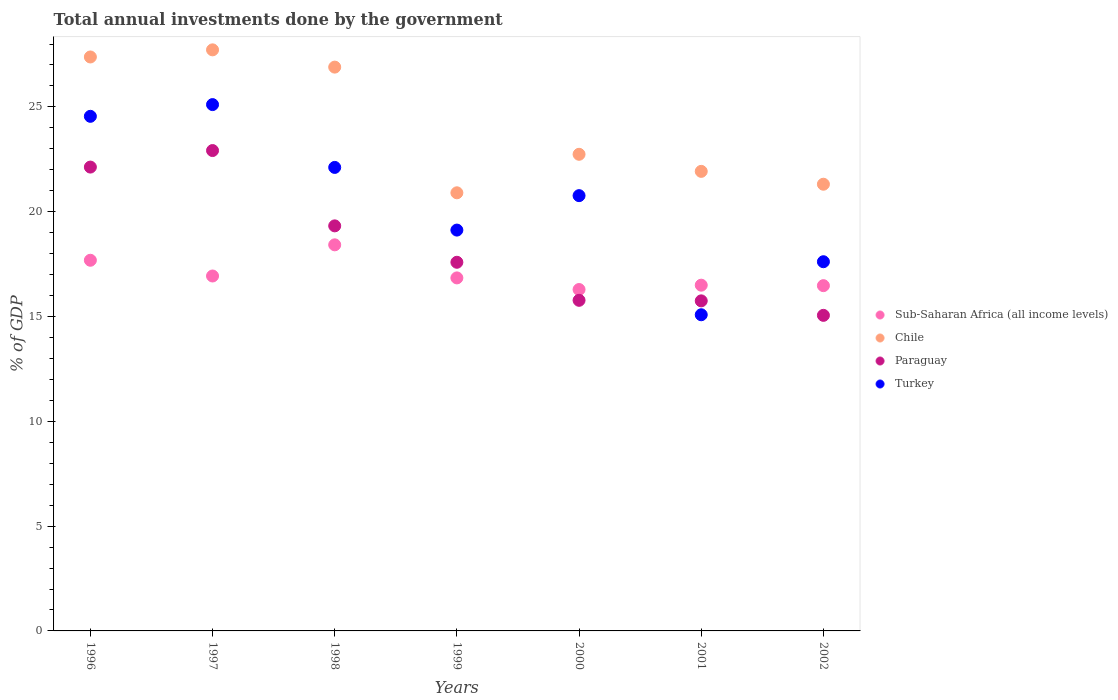Is the number of dotlines equal to the number of legend labels?
Offer a very short reply. Yes. What is the total annual investments done by the government in Paraguay in 2000?
Provide a succinct answer. 15.77. Across all years, what is the maximum total annual investments done by the government in Chile?
Offer a terse response. 27.72. Across all years, what is the minimum total annual investments done by the government in Paraguay?
Offer a very short reply. 15.06. In which year was the total annual investments done by the government in Sub-Saharan Africa (all income levels) minimum?
Offer a terse response. 2000. What is the total total annual investments done by the government in Chile in the graph?
Make the answer very short. 168.88. What is the difference between the total annual investments done by the government in Turkey in 1996 and that in 1998?
Offer a terse response. 2.44. What is the difference between the total annual investments done by the government in Chile in 2002 and the total annual investments done by the government in Turkey in 1996?
Give a very brief answer. -3.24. What is the average total annual investments done by the government in Paraguay per year?
Your answer should be compact. 18.36. In the year 1998, what is the difference between the total annual investments done by the government in Turkey and total annual investments done by the government in Chile?
Offer a terse response. -4.79. In how many years, is the total annual investments done by the government in Turkey greater than 2 %?
Give a very brief answer. 7. What is the ratio of the total annual investments done by the government in Turkey in 1999 to that in 2001?
Your answer should be very brief. 1.27. Is the total annual investments done by the government in Turkey in 1997 less than that in 2000?
Offer a terse response. No. Is the difference between the total annual investments done by the government in Turkey in 1998 and 2001 greater than the difference between the total annual investments done by the government in Chile in 1998 and 2001?
Provide a succinct answer. Yes. What is the difference between the highest and the second highest total annual investments done by the government in Sub-Saharan Africa (all income levels)?
Give a very brief answer. 0.74. What is the difference between the highest and the lowest total annual investments done by the government in Chile?
Make the answer very short. 6.82. In how many years, is the total annual investments done by the government in Paraguay greater than the average total annual investments done by the government in Paraguay taken over all years?
Offer a terse response. 3. Is it the case that in every year, the sum of the total annual investments done by the government in Paraguay and total annual investments done by the government in Turkey  is greater than the total annual investments done by the government in Chile?
Provide a succinct answer. Yes. Does the total annual investments done by the government in Turkey monotonically increase over the years?
Keep it short and to the point. No. Is the total annual investments done by the government in Turkey strictly less than the total annual investments done by the government in Chile over the years?
Your response must be concise. Yes. How many dotlines are there?
Ensure brevity in your answer.  4. How many years are there in the graph?
Offer a very short reply. 7. Are the values on the major ticks of Y-axis written in scientific E-notation?
Make the answer very short. No. Does the graph contain any zero values?
Provide a succinct answer. No. Does the graph contain grids?
Your answer should be very brief. No. Where does the legend appear in the graph?
Your response must be concise. Center right. How many legend labels are there?
Offer a terse response. 4. What is the title of the graph?
Offer a terse response. Total annual investments done by the government. Does "Armenia" appear as one of the legend labels in the graph?
Make the answer very short. No. What is the label or title of the Y-axis?
Your answer should be compact. % of GDP. What is the % of GDP of Sub-Saharan Africa (all income levels) in 1996?
Make the answer very short. 17.68. What is the % of GDP of Chile in 1996?
Make the answer very short. 27.38. What is the % of GDP of Paraguay in 1996?
Give a very brief answer. 22.13. What is the % of GDP of Turkey in 1996?
Keep it short and to the point. 24.55. What is the % of GDP in Sub-Saharan Africa (all income levels) in 1997?
Make the answer very short. 16.93. What is the % of GDP of Chile in 1997?
Offer a terse response. 27.72. What is the % of GDP of Paraguay in 1997?
Offer a terse response. 22.92. What is the % of GDP in Turkey in 1997?
Ensure brevity in your answer.  25.11. What is the % of GDP of Sub-Saharan Africa (all income levels) in 1998?
Your answer should be very brief. 18.42. What is the % of GDP in Chile in 1998?
Give a very brief answer. 26.9. What is the % of GDP in Paraguay in 1998?
Offer a terse response. 19.32. What is the % of GDP of Turkey in 1998?
Offer a very short reply. 22.11. What is the % of GDP of Sub-Saharan Africa (all income levels) in 1999?
Offer a very short reply. 16.84. What is the % of GDP of Chile in 1999?
Keep it short and to the point. 20.9. What is the % of GDP of Paraguay in 1999?
Offer a terse response. 17.59. What is the % of GDP of Turkey in 1999?
Your response must be concise. 19.12. What is the % of GDP of Sub-Saharan Africa (all income levels) in 2000?
Your response must be concise. 16.29. What is the % of GDP in Chile in 2000?
Offer a terse response. 22.74. What is the % of GDP in Paraguay in 2000?
Keep it short and to the point. 15.77. What is the % of GDP in Turkey in 2000?
Keep it short and to the point. 20.77. What is the % of GDP of Sub-Saharan Africa (all income levels) in 2001?
Offer a very short reply. 16.5. What is the % of GDP of Chile in 2001?
Offer a very short reply. 21.92. What is the % of GDP of Paraguay in 2001?
Keep it short and to the point. 15.75. What is the % of GDP of Turkey in 2001?
Give a very brief answer. 15.08. What is the % of GDP of Sub-Saharan Africa (all income levels) in 2002?
Offer a terse response. 16.47. What is the % of GDP of Chile in 2002?
Provide a short and direct response. 21.31. What is the % of GDP in Paraguay in 2002?
Your answer should be compact. 15.06. What is the % of GDP of Turkey in 2002?
Make the answer very short. 17.61. Across all years, what is the maximum % of GDP in Sub-Saharan Africa (all income levels)?
Offer a terse response. 18.42. Across all years, what is the maximum % of GDP in Chile?
Offer a very short reply. 27.72. Across all years, what is the maximum % of GDP of Paraguay?
Ensure brevity in your answer.  22.92. Across all years, what is the maximum % of GDP in Turkey?
Offer a very short reply. 25.11. Across all years, what is the minimum % of GDP of Sub-Saharan Africa (all income levels)?
Your answer should be compact. 16.29. Across all years, what is the minimum % of GDP of Chile?
Your response must be concise. 20.9. Across all years, what is the minimum % of GDP of Paraguay?
Provide a short and direct response. 15.06. Across all years, what is the minimum % of GDP of Turkey?
Keep it short and to the point. 15.08. What is the total % of GDP of Sub-Saharan Africa (all income levels) in the graph?
Your answer should be compact. 119.14. What is the total % of GDP of Chile in the graph?
Your response must be concise. 168.88. What is the total % of GDP of Paraguay in the graph?
Keep it short and to the point. 128.54. What is the total % of GDP in Turkey in the graph?
Give a very brief answer. 144.36. What is the difference between the % of GDP of Sub-Saharan Africa (all income levels) in 1996 and that in 1997?
Keep it short and to the point. 0.75. What is the difference between the % of GDP in Chile in 1996 and that in 1997?
Offer a terse response. -0.34. What is the difference between the % of GDP of Paraguay in 1996 and that in 1997?
Your answer should be very brief. -0.79. What is the difference between the % of GDP in Turkey in 1996 and that in 1997?
Make the answer very short. -0.56. What is the difference between the % of GDP of Sub-Saharan Africa (all income levels) in 1996 and that in 1998?
Keep it short and to the point. -0.74. What is the difference between the % of GDP in Chile in 1996 and that in 1998?
Provide a succinct answer. 0.48. What is the difference between the % of GDP of Paraguay in 1996 and that in 1998?
Keep it short and to the point. 2.8. What is the difference between the % of GDP of Turkey in 1996 and that in 1998?
Your answer should be compact. 2.44. What is the difference between the % of GDP of Sub-Saharan Africa (all income levels) in 1996 and that in 1999?
Provide a succinct answer. 0.84. What is the difference between the % of GDP of Chile in 1996 and that in 1999?
Your response must be concise. 6.48. What is the difference between the % of GDP in Paraguay in 1996 and that in 1999?
Provide a succinct answer. 4.54. What is the difference between the % of GDP of Turkey in 1996 and that in 1999?
Offer a very short reply. 5.43. What is the difference between the % of GDP of Sub-Saharan Africa (all income levels) in 1996 and that in 2000?
Make the answer very short. 1.4. What is the difference between the % of GDP in Chile in 1996 and that in 2000?
Your response must be concise. 4.64. What is the difference between the % of GDP in Paraguay in 1996 and that in 2000?
Ensure brevity in your answer.  6.36. What is the difference between the % of GDP in Turkey in 1996 and that in 2000?
Give a very brief answer. 3.78. What is the difference between the % of GDP in Sub-Saharan Africa (all income levels) in 1996 and that in 2001?
Offer a terse response. 1.19. What is the difference between the % of GDP of Chile in 1996 and that in 2001?
Provide a short and direct response. 5.46. What is the difference between the % of GDP of Paraguay in 1996 and that in 2001?
Your answer should be very brief. 6.38. What is the difference between the % of GDP of Turkey in 1996 and that in 2001?
Your answer should be compact. 9.47. What is the difference between the % of GDP of Sub-Saharan Africa (all income levels) in 1996 and that in 2002?
Keep it short and to the point. 1.21. What is the difference between the % of GDP in Chile in 1996 and that in 2002?
Keep it short and to the point. 6.07. What is the difference between the % of GDP in Paraguay in 1996 and that in 2002?
Make the answer very short. 7.07. What is the difference between the % of GDP of Turkey in 1996 and that in 2002?
Make the answer very short. 6.94. What is the difference between the % of GDP in Sub-Saharan Africa (all income levels) in 1997 and that in 1998?
Your response must be concise. -1.49. What is the difference between the % of GDP of Chile in 1997 and that in 1998?
Provide a short and direct response. 0.82. What is the difference between the % of GDP of Paraguay in 1997 and that in 1998?
Your answer should be compact. 3.59. What is the difference between the % of GDP in Turkey in 1997 and that in 1998?
Your response must be concise. 3. What is the difference between the % of GDP in Sub-Saharan Africa (all income levels) in 1997 and that in 1999?
Your answer should be very brief. 0.09. What is the difference between the % of GDP of Chile in 1997 and that in 1999?
Ensure brevity in your answer.  6.82. What is the difference between the % of GDP in Paraguay in 1997 and that in 1999?
Provide a succinct answer. 5.33. What is the difference between the % of GDP in Turkey in 1997 and that in 1999?
Provide a succinct answer. 5.99. What is the difference between the % of GDP in Sub-Saharan Africa (all income levels) in 1997 and that in 2000?
Give a very brief answer. 0.65. What is the difference between the % of GDP of Chile in 1997 and that in 2000?
Your answer should be very brief. 4.98. What is the difference between the % of GDP of Paraguay in 1997 and that in 2000?
Your answer should be very brief. 7.15. What is the difference between the % of GDP in Turkey in 1997 and that in 2000?
Keep it short and to the point. 4.34. What is the difference between the % of GDP of Sub-Saharan Africa (all income levels) in 1997 and that in 2001?
Provide a short and direct response. 0.44. What is the difference between the % of GDP of Chile in 1997 and that in 2001?
Offer a terse response. 5.8. What is the difference between the % of GDP in Paraguay in 1997 and that in 2001?
Make the answer very short. 7.17. What is the difference between the % of GDP in Turkey in 1997 and that in 2001?
Provide a succinct answer. 10.03. What is the difference between the % of GDP of Sub-Saharan Africa (all income levels) in 1997 and that in 2002?
Offer a very short reply. 0.46. What is the difference between the % of GDP in Chile in 1997 and that in 2002?
Your response must be concise. 6.41. What is the difference between the % of GDP of Paraguay in 1997 and that in 2002?
Provide a succinct answer. 7.86. What is the difference between the % of GDP in Turkey in 1997 and that in 2002?
Your answer should be very brief. 7.5. What is the difference between the % of GDP in Sub-Saharan Africa (all income levels) in 1998 and that in 1999?
Offer a terse response. 1.58. What is the difference between the % of GDP in Chile in 1998 and that in 1999?
Provide a short and direct response. 6. What is the difference between the % of GDP of Paraguay in 1998 and that in 1999?
Provide a succinct answer. 1.74. What is the difference between the % of GDP in Turkey in 1998 and that in 1999?
Your answer should be very brief. 2.99. What is the difference between the % of GDP of Sub-Saharan Africa (all income levels) in 1998 and that in 2000?
Offer a very short reply. 2.13. What is the difference between the % of GDP of Chile in 1998 and that in 2000?
Your response must be concise. 4.16. What is the difference between the % of GDP in Paraguay in 1998 and that in 2000?
Your response must be concise. 3.55. What is the difference between the % of GDP of Turkey in 1998 and that in 2000?
Keep it short and to the point. 1.35. What is the difference between the % of GDP of Sub-Saharan Africa (all income levels) in 1998 and that in 2001?
Make the answer very short. 1.92. What is the difference between the % of GDP of Chile in 1998 and that in 2001?
Your response must be concise. 4.97. What is the difference between the % of GDP of Paraguay in 1998 and that in 2001?
Your response must be concise. 3.58. What is the difference between the % of GDP in Turkey in 1998 and that in 2001?
Provide a succinct answer. 7.03. What is the difference between the % of GDP of Sub-Saharan Africa (all income levels) in 1998 and that in 2002?
Keep it short and to the point. 1.95. What is the difference between the % of GDP of Chile in 1998 and that in 2002?
Provide a succinct answer. 5.59. What is the difference between the % of GDP of Paraguay in 1998 and that in 2002?
Your response must be concise. 4.27. What is the difference between the % of GDP of Turkey in 1998 and that in 2002?
Your answer should be very brief. 4.5. What is the difference between the % of GDP in Sub-Saharan Africa (all income levels) in 1999 and that in 2000?
Provide a succinct answer. 0.55. What is the difference between the % of GDP of Chile in 1999 and that in 2000?
Give a very brief answer. -1.84. What is the difference between the % of GDP in Paraguay in 1999 and that in 2000?
Your response must be concise. 1.82. What is the difference between the % of GDP in Turkey in 1999 and that in 2000?
Keep it short and to the point. -1.64. What is the difference between the % of GDP of Sub-Saharan Africa (all income levels) in 1999 and that in 2001?
Your answer should be compact. 0.35. What is the difference between the % of GDP in Chile in 1999 and that in 2001?
Ensure brevity in your answer.  -1.02. What is the difference between the % of GDP of Paraguay in 1999 and that in 2001?
Your response must be concise. 1.84. What is the difference between the % of GDP of Turkey in 1999 and that in 2001?
Ensure brevity in your answer.  4.04. What is the difference between the % of GDP of Sub-Saharan Africa (all income levels) in 1999 and that in 2002?
Make the answer very short. 0.37. What is the difference between the % of GDP of Chile in 1999 and that in 2002?
Keep it short and to the point. -0.41. What is the difference between the % of GDP of Paraguay in 1999 and that in 2002?
Provide a short and direct response. 2.53. What is the difference between the % of GDP of Turkey in 1999 and that in 2002?
Offer a very short reply. 1.51. What is the difference between the % of GDP in Sub-Saharan Africa (all income levels) in 2000 and that in 2001?
Keep it short and to the point. -0.21. What is the difference between the % of GDP in Chile in 2000 and that in 2001?
Offer a terse response. 0.81. What is the difference between the % of GDP in Paraguay in 2000 and that in 2001?
Make the answer very short. 0.03. What is the difference between the % of GDP of Turkey in 2000 and that in 2001?
Your answer should be compact. 5.68. What is the difference between the % of GDP of Sub-Saharan Africa (all income levels) in 2000 and that in 2002?
Your answer should be very brief. -0.18. What is the difference between the % of GDP in Chile in 2000 and that in 2002?
Your response must be concise. 1.43. What is the difference between the % of GDP in Paraguay in 2000 and that in 2002?
Offer a very short reply. 0.72. What is the difference between the % of GDP of Turkey in 2000 and that in 2002?
Ensure brevity in your answer.  3.15. What is the difference between the % of GDP in Sub-Saharan Africa (all income levels) in 2001 and that in 2002?
Provide a succinct answer. 0.02. What is the difference between the % of GDP in Chile in 2001 and that in 2002?
Offer a terse response. 0.61. What is the difference between the % of GDP in Paraguay in 2001 and that in 2002?
Make the answer very short. 0.69. What is the difference between the % of GDP of Turkey in 2001 and that in 2002?
Offer a terse response. -2.53. What is the difference between the % of GDP in Sub-Saharan Africa (all income levels) in 1996 and the % of GDP in Chile in 1997?
Keep it short and to the point. -10.04. What is the difference between the % of GDP in Sub-Saharan Africa (all income levels) in 1996 and the % of GDP in Paraguay in 1997?
Your answer should be very brief. -5.23. What is the difference between the % of GDP of Sub-Saharan Africa (all income levels) in 1996 and the % of GDP of Turkey in 1997?
Offer a very short reply. -7.43. What is the difference between the % of GDP of Chile in 1996 and the % of GDP of Paraguay in 1997?
Offer a terse response. 4.46. What is the difference between the % of GDP in Chile in 1996 and the % of GDP in Turkey in 1997?
Make the answer very short. 2.27. What is the difference between the % of GDP of Paraguay in 1996 and the % of GDP of Turkey in 1997?
Make the answer very short. -2.98. What is the difference between the % of GDP of Sub-Saharan Africa (all income levels) in 1996 and the % of GDP of Chile in 1998?
Offer a very short reply. -9.21. What is the difference between the % of GDP of Sub-Saharan Africa (all income levels) in 1996 and the % of GDP of Paraguay in 1998?
Ensure brevity in your answer.  -1.64. What is the difference between the % of GDP of Sub-Saharan Africa (all income levels) in 1996 and the % of GDP of Turkey in 1998?
Offer a terse response. -4.43. What is the difference between the % of GDP of Chile in 1996 and the % of GDP of Paraguay in 1998?
Give a very brief answer. 8.06. What is the difference between the % of GDP in Chile in 1996 and the % of GDP in Turkey in 1998?
Offer a very short reply. 5.27. What is the difference between the % of GDP of Paraguay in 1996 and the % of GDP of Turkey in 1998?
Give a very brief answer. 0.02. What is the difference between the % of GDP of Sub-Saharan Africa (all income levels) in 1996 and the % of GDP of Chile in 1999?
Offer a very short reply. -3.22. What is the difference between the % of GDP in Sub-Saharan Africa (all income levels) in 1996 and the % of GDP in Paraguay in 1999?
Offer a very short reply. 0.1. What is the difference between the % of GDP in Sub-Saharan Africa (all income levels) in 1996 and the % of GDP in Turkey in 1999?
Provide a short and direct response. -1.44. What is the difference between the % of GDP in Chile in 1996 and the % of GDP in Paraguay in 1999?
Offer a very short reply. 9.79. What is the difference between the % of GDP of Chile in 1996 and the % of GDP of Turkey in 1999?
Keep it short and to the point. 8.26. What is the difference between the % of GDP in Paraguay in 1996 and the % of GDP in Turkey in 1999?
Provide a succinct answer. 3.01. What is the difference between the % of GDP in Sub-Saharan Africa (all income levels) in 1996 and the % of GDP in Chile in 2000?
Ensure brevity in your answer.  -5.05. What is the difference between the % of GDP of Sub-Saharan Africa (all income levels) in 1996 and the % of GDP of Paraguay in 2000?
Offer a terse response. 1.91. What is the difference between the % of GDP in Sub-Saharan Africa (all income levels) in 1996 and the % of GDP in Turkey in 2000?
Offer a terse response. -3.08. What is the difference between the % of GDP of Chile in 1996 and the % of GDP of Paraguay in 2000?
Make the answer very short. 11.61. What is the difference between the % of GDP of Chile in 1996 and the % of GDP of Turkey in 2000?
Give a very brief answer. 6.62. What is the difference between the % of GDP of Paraguay in 1996 and the % of GDP of Turkey in 2000?
Ensure brevity in your answer.  1.36. What is the difference between the % of GDP of Sub-Saharan Africa (all income levels) in 1996 and the % of GDP of Chile in 2001?
Provide a short and direct response. -4.24. What is the difference between the % of GDP of Sub-Saharan Africa (all income levels) in 1996 and the % of GDP of Paraguay in 2001?
Provide a short and direct response. 1.94. What is the difference between the % of GDP of Sub-Saharan Africa (all income levels) in 1996 and the % of GDP of Turkey in 2001?
Give a very brief answer. 2.6. What is the difference between the % of GDP of Chile in 1996 and the % of GDP of Paraguay in 2001?
Provide a succinct answer. 11.64. What is the difference between the % of GDP of Chile in 1996 and the % of GDP of Turkey in 2001?
Offer a terse response. 12.3. What is the difference between the % of GDP of Paraguay in 1996 and the % of GDP of Turkey in 2001?
Give a very brief answer. 7.05. What is the difference between the % of GDP of Sub-Saharan Africa (all income levels) in 1996 and the % of GDP of Chile in 2002?
Your answer should be compact. -3.63. What is the difference between the % of GDP in Sub-Saharan Africa (all income levels) in 1996 and the % of GDP in Paraguay in 2002?
Make the answer very short. 2.63. What is the difference between the % of GDP of Sub-Saharan Africa (all income levels) in 1996 and the % of GDP of Turkey in 2002?
Your answer should be compact. 0.07. What is the difference between the % of GDP of Chile in 1996 and the % of GDP of Paraguay in 2002?
Offer a terse response. 12.33. What is the difference between the % of GDP of Chile in 1996 and the % of GDP of Turkey in 2002?
Give a very brief answer. 9.77. What is the difference between the % of GDP of Paraguay in 1996 and the % of GDP of Turkey in 2002?
Your answer should be compact. 4.52. What is the difference between the % of GDP of Sub-Saharan Africa (all income levels) in 1997 and the % of GDP of Chile in 1998?
Ensure brevity in your answer.  -9.97. What is the difference between the % of GDP of Sub-Saharan Africa (all income levels) in 1997 and the % of GDP of Paraguay in 1998?
Your answer should be very brief. -2.39. What is the difference between the % of GDP of Sub-Saharan Africa (all income levels) in 1997 and the % of GDP of Turkey in 1998?
Give a very brief answer. -5.18. What is the difference between the % of GDP in Chile in 1997 and the % of GDP in Paraguay in 1998?
Ensure brevity in your answer.  8.4. What is the difference between the % of GDP in Chile in 1997 and the % of GDP in Turkey in 1998?
Your response must be concise. 5.61. What is the difference between the % of GDP in Paraguay in 1997 and the % of GDP in Turkey in 1998?
Make the answer very short. 0.8. What is the difference between the % of GDP of Sub-Saharan Africa (all income levels) in 1997 and the % of GDP of Chile in 1999?
Provide a succinct answer. -3.97. What is the difference between the % of GDP in Sub-Saharan Africa (all income levels) in 1997 and the % of GDP in Paraguay in 1999?
Keep it short and to the point. -0.65. What is the difference between the % of GDP of Sub-Saharan Africa (all income levels) in 1997 and the % of GDP of Turkey in 1999?
Your response must be concise. -2.19. What is the difference between the % of GDP in Chile in 1997 and the % of GDP in Paraguay in 1999?
Give a very brief answer. 10.13. What is the difference between the % of GDP of Chile in 1997 and the % of GDP of Turkey in 1999?
Ensure brevity in your answer.  8.6. What is the difference between the % of GDP of Paraguay in 1997 and the % of GDP of Turkey in 1999?
Offer a very short reply. 3.79. What is the difference between the % of GDP of Sub-Saharan Africa (all income levels) in 1997 and the % of GDP of Chile in 2000?
Give a very brief answer. -5.81. What is the difference between the % of GDP of Sub-Saharan Africa (all income levels) in 1997 and the % of GDP of Paraguay in 2000?
Offer a terse response. 1.16. What is the difference between the % of GDP in Sub-Saharan Africa (all income levels) in 1997 and the % of GDP in Turkey in 2000?
Your response must be concise. -3.83. What is the difference between the % of GDP in Chile in 1997 and the % of GDP in Paraguay in 2000?
Your answer should be compact. 11.95. What is the difference between the % of GDP in Chile in 1997 and the % of GDP in Turkey in 2000?
Offer a terse response. 6.96. What is the difference between the % of GDP of Paraguay in 1997 and the % of GDP of Turkey in 2000?
Offer a very short reply. 2.15. What is the difference between the % of GDP of Sub-Saharan Africa (all income levels) in 1997 and the % of GDP of Chile in 2001?
Make the answer very short. -4.99. What is the difference between the % of GDP in Sub-Saharan Africa (all income levels) in 1997 and the % of GDP in Paraguay in 2001?
Ensure brevity in your answer.  1.19. What is the difference between the % of GDP in Sub-Saharan Africa (all income levels) in 1997 and the % of GDP in Turkey in 2001?
Offer a terse response. 1.85. What is the difference between the % of GDP of Chile in 1997 and the % of GDP of Paraguay in 2001?
Provide a succinct answer. 11.98. What is the difference between the % of GDP of Chile in 1997 and the % of GDP of Turkey in 2001?
Ensure brevity in your answer.  12.64. What is the difference between the % of GDP in Paraguay in 1997 and the % of GDP in Turkey in 2001?
Give a very brief answer. 7.83. What is the difference between the % of GDP of Sub-Saharan Africa (all income levels) in 1997 and the % of GDP of Chile in 2002?
Ensure brevity in your answer.  -4.38. What is the difference between the % of GDP in Sub-Saharan Africa (all income levels) in 1997 and the % of GDP in Paraguay in 2002?
Offer a terse response. 1.88. What is the difference between the % of GDP of Sub-Saharan Africa (all income levels) in 1997 and the % of GDP of Turkey in 2002?
Provide a short and direct response. -0.68. What is the difference between the % of GDP in Chile in 1997 and the % of GDP in Paraguay in 2002?
Offer a very short reply. 12.67. What is the difference between the % of GDP in Chile in 1997 and the % of GDP in Turkey in 2002?
Your answer should be very brief. 10.11. What is the difference between the % of GDP of Paraguay in 1997 and the % of GDP of Turkey in 2002?
Your response must be concise. 5.3. What is the difference between the % of GDP of Sub-Saharan Africa (all income levels) in 1998 and the % of GDP of Chile in 1999?
Make the answer very short. -2.48. What is the difference between the % of GDP of Sub-Saharan Africa (all income levels) in 1998 and the % of GDP of Paraguay in 1999?
Give a very brief answer. 0.83. What is the difference between the % of GDP of Sub-Saharan Africa (all income levels) in 1998 and the % of GDP of Turkey in 1999?
Give a very brief answer. -0.7. What is the difference between the % of GDP of Chile in 1998 and the % of GDP of Paraguay in 1999?
Offer a very short reply. 9.31. What is the difference between the % of GDP in Chile in 1998 and the % of GDP in Turkey in 1999?
Offer a very short reply. 7.78. What is the difference between the % of GDP in Paraguay in 1998 and the % of GDP in Turkey in 1999?
Ensure brevity in your answer.  0.2. What is the difference between the % of GDP of Sub-Saharan Africa (all income levels) in 1998 and the % of GDP of Chile in 2000?
Make the answer very short. -4.32. What is the difference between the % of GDP in Sub-Saharan Africa (all income levels) in 1998 and the % of GDP in Paraguay in 2000?
Offer a very short reply. 2.65. What is the difference between the % of GDP in Sub-Saharan Africa (all income levels) in 1998 and the % of GDP in Turkey in 2000?
Offer a terse response. -2.35. What is the difference between the % of GDP in Chile in 1998 and the % of GDP in Paraguay in 2000?
Offer a terse response. 11.13. What is the difference between the % of GDP of Chile in 1998 and the % of GDP of Turkey in 2000?
Give a very brief answer. 6.13. What is the difference between the % of GDP of Paraguay in 1998 and the % of GDP of Turkey in 2000?
Offer a terse response. -1.44. What is the difference between the % of GDP of Sub-Saharan Africa (all income levels) in 1998 and the % of GDP of Chile in 2001?
Your response must be concise. -3.5. What is the difference between the % of GDP of Sub-Saharan Africa (all income levels) in 1998 and the % of GDP of Paraguay in 2001?
Provide a short and direct response. 2.67. What is the difference between the % of GDP of Sub-Saharan Africa (all income levels) in 1998 and the % of GDP of Turkey in 2001?
Offer a very short reply. 3.34. What is the difference between the % of GDP in Chile in 1998 and the % of GDP in Paraguay in 2001?
Make the answer very short. 11.15. What is the difference between the % of GDP in Chile in 1998 and the % of GDP in Turkey in 2001?
Make the answer very short. 11.81. What is the difference between the % of GDP in Paraguay in 1998 and the % of GDP in Turkey in 2001?
Give a very brief answer. 4.24. What is the difference between the % of GDP of Sub-Saharan Africa (all income levels) in 1998 and the % of GDP of Chile in 2002?
Give a very brief answer. -2.89. What is the difference between the % of GDP of Sub-Saharan Africa (all income levels) in 1998 and the % of GDP of Paraguay in 2002?
Your response must be concise. 3.36. What is the difference between the % of GDP of Sub-Saharan Africa (all income levels) in 1998 and the % of GDP of Turkey in 2002?
Offer a terse response. 0.81. What is the difference between the % of GDP in Chile in 1998 and the % of GDP in Paraguay in 2002?
Your response must be concise. 11.84. What is the difference between the % of GDP of Chile in 1998 and the % of GDP of Turkey in 2002?
Give a very brief answer. 9.28. What is the difference between the % of GDP in Paraguay in 1998 and the % of GDP in Turkey in 2002?
Your answer should be compact. 1.71. What is the difference between the % of GDP in Sub-Saharan Africa (all income levels) in 1999 and the % of GDP in Chile in 2000?
Keep it short and to the point. -5.9. What is the difference between the % of GDP in Sub-Saharan Africa (all income levels) in 1999 and the % of GDP in Paraguay in 2000?
Provide a succinct answer. 1.07. What is the difference between the % of GDP in Sub-Saharan Africa (all income levels) in 1999 and the % of GDP in Turkey in 2000?
Make the answer very short. -3.92. What is the difference between the % of GDP of Chile in 1999 and the % of GDP of Paraguay in 2000?
Provide a short and direct response. 5.13. What is the difference between the % of GDP in Chile in 1999 and the % of GDP in Turkey in 2000?
Make the answer very short. 0.14. What is the difference between the % of GDP in Paraguay in 1999 and the % of GDP in Turkey in 2000?
Make the answer very short. -3.18. What is the difference between the % of GDP of Sub-Saharan Africa (all income levels) in 1999 and the % of GDP of Chile in 2001?
Your response must be concise. -5.08. What is the difference between the % of GDP of Sub-Saharan Africa (all income levels) in 1999 and the % of GDP of Paraguay in 2001?
Give a very brief answer. 1.1. What is the difference between the % of GDP of Sub-Saharan Africa (all income levels) in 1999 and the % of GDP of Turkey in 2001?
Give a very brief answer. 1.76. What is the difference between the % of GDP in Chile in 1999 and the % of GDP in Paraguay in 2001?
Give a very brief answer. 5.16. What is the difference between the % of GDP of Chile in 1999 and the % of GDP of Turkey in 2001?
Make the answer very short. 5.82. What is the difference between the % of GDP in Paraguay in 1999 and the % of GDP in Turkey in 2001?
Make the answer very short. 2.5. What is the difference between the % of GDP of Sub-Saharan Africa (all income levels) in 1999 and the % of GDP of Chile in 2002?
Your answer should be compact. -4.47. What is the difference between the % of GDP in Sub-Saharan Africa (all income levels) in 1999 and the % of GDP in Paraguay in 2002?
Your response must be concise. 1.79. What is the difference between the % of GDP of Sub-Saharan Africa (all income levels) in 1999 and the % of GDP of Turkey in 2002?
Your answer should be compact. -0.77. What is the difference between the % of GDP of Chile in 1999 and the % of GDP of Paraguay in 2002?
Your response must be concise. 5.85. What is the difference between the % of GDP of Chile in 1999 and the % of GDP of Turkey in 2002?
Ensure brevity in your answer.  3.29. What is the difference between the % of GDP in Paraguay in 1999 and the % of GDP in Turkey in 2002?
Provide a succinct answer. -0.03. What is the difference between the % of GDP of Sub-Saharan Africa (all income levels) in 2000 and the % of GDP of Chile in 2001?
Make the answer very short. -5.64. What is the difference between the % of GDP in Sub-Saharan Africa (all income levels) in 2000 and the % of GDP in Paraguay in 2001?
Ensure brevity in your answer.  0.54. What is the difference between the % of GDP in Sub-Saharan Africa (all income levels) in 2000 and the % of GDP in Turkey in 2001?
Give a very brief answer. 1.2. What is the difference between the % of GDP in Chile in 2000 and the % of GDP in Paraguay in 2001?
Offer a very short reply. 6.99. What is the difference between the % of GDP of Chile in 2000 and the % of GDP of Turkey in 2001?
Make the answer very short. 7.66. What is the difference between the % of GDP in Paraguay in 2000 and the % of GDP in Turkey in 2001?
Make the answer very short. 0.69. What is the difference between the % of GDP in Sub-Saharan Africa (all income levels) in 2000 and the % of GDP in Chile in 2002?
Offer a very short reply. -5.02. What is the difference between the % of GDP in Sub-Saharan Africa (all income levels) in 2000 and the % of GDP in Paraguay in 2002?
Keep it short and to the point. 1.23. What is the difference between the % of GDP in Sub-Saharan Africa (all income levels) in 2000 and the % of GDP in Turkey in 2002?
Give a very brief answer. -1.33. What is the difference between the % of GDP in Chile in 2000 and the % of GDP in Paraguay in 2002?
Make the answer very short. 7.68. What is the difference between the % of GDP of Chile in 2000 and the % of GDP of Turkey in 2002?
Your answer should be compact. 5.13. What is the difference between the % of GDP in Paraguay in 2000 and the % of GDP in Turkey in 2002?
Make the answer very short. -1.84. What is the difference between the % of GDP of Sub-Saharan Africa (all income levels) in 2001 and the % of GDP of Chile in 2002?
Offer a terse response. -4.82. What is the difference between the % of GDP of Sub-Saharan Africa (all income levels) in 2001 and the % of GDP of Paraguay in 2002?
Offer a very short reply. 1.44. What is the difference between the % of GDP of Sub-Saharan Africa (all income levels) in 2001 and the % of GDP of Turkey in 2002?
Ensure brevity in your answer.  -1.12. What is the difference between the % of GDP of Chile in 2001 and the % of GDP of Paraguay in 2002?
Your answer should be very brief. 6.87. What is the difference between the % of GDP of Chile in 2001 and the % of GDP of Turkey in 2002?
Keep it short and to the point. 4.31. What is the difference between the % of GDP of Paraguay in 2001 and the % of GDP of Turkey in 2002?
Your answer should be very brief. -1.87. What is the average % of GDP of Sub-Saharan Africa (all income levels) per year?
Give a very brief answer. 17.02. What is the average % of GDP in Chile per year?
Offer a very short reply. 24.13. What is the average % of GDP of Paraguay per year?
Give a very brief answer. 18.36. What is the average % of GDP in Turkey per year?
Offer a very short reply. 20.62. In the year 1996, what is the difference between the % of GDP of Sub-Saharan Africa (all income levels) and % of GDP of Chile?
Offer a very short reply. -9.7. In the year 1996, what is the difference between the % of GDP of Sub-Saharan Africa (all income levels) and % of GDP of Paraguay?
Give a very brief answer. -4.45. In the year 1996, what is the difference between the % of GDP of Sub-Saharan Africa (all income levels) and % of GDP of Turkey?
Offer a very short reply. -6.87. In the year 1996, what is the difference between the % of GDP of Chile and % of GDP of Paraguay?
Your response must be concise. 5.25. In the year 1996, what is the difference between the % of GDP of Chile and % of GDP of Turkey?
Your answer should be very brief. 2.83. In the year 1996, what is the difference between the % of GDP of Paraguay and % of GDP of Turkey?
Provide a succinct answer. -2.42. In the year 1997, what is the difference between the % of GDP in Sub-Saharan Africa (all income levels) and % of GDP in Chile?
Give a very brief answer. -10.79. In the year 1997, what is the difference between the % of GDP in Sub-Saharan Africa (all income levels) and % of GDP in Paraguay?
Offer a terse response. -5.99. In the year 1997, what is the difference between the % of GDP of Sub-Saharan Africa (all income levels) and % of GDP of Turkey?
Keep it short and to the point. -8.18. In the year 1997, what is the difference between the % of GDP of Chile and % of GDP of Paraguay?
Make the answer very short. 4.8. In the year 1997, what is the difference between the % of GDP of Chile and % of GDP of Turkey?
Provide a short and direct response. 2.61. In the year 1997, what is the difference between the % of GDP of Paraguay and % of GDP of Turkey?
Offer a very short reply. -2.19. In the year 1998, what is the difference between the % of GDP of Sub-Saharan Africa (all income levels) and % of GDP of Chile?
Keep it short and to the point. -8.48. In the year 1998, what is the difference between the % of GDP of Sub-Saharan Africa (all income levels) and % of GDP of Paraguay?
Your answer should be very brief. -0.9. In the year 1998, what is the difference between the % of GDP of Sub-Saharan Africa (all income levels) and % of GDP of Turkey?
Offer a terse response. -3.69. In the year 1998, what is the difference between the % of GDP of Chile and % of GDP of Paraguay?
Offer a very short reply. 7.57. In the year 1998, what is the difference between the % of GDP of Chile and % of GDP of Turkey?
Offer a very short reply. 4.79. In the year 1998, what is the difference between the % of GDP in Paraguay and % of GDP in Turkey?
Your answer should be very brief. -2.79. In the year 1999, what is the difference between the % of GDP in Sub-Saharan Africa (all income levels) and % of GDP in Chile?
Provide a succinct answer. -4.06. In the year 1999, what is the difference between the % of GDP in Sub-Saharan Africa (all income levels) and % of GDP in Paraguay?
Your answer should be very brief. -0.75. In the year 1999, what is the difference between the % of GDP of Sub-Saharan Africa (all income levels) and % of GDP of Turkey?
Ensure brevity in your answer.  -2.28. In the year 1999, what is the difference between the % of GDP of Chile and % of GDP of Paraguay?
Give a very brief answer. 3.31. In the year 1999, what is the difference between the % of GDP in Chile and % of GDP in Turkey?
Keep it short and to the point. 1.78. In the year 1999, what is the difference between the % of GDP in Paraguay and % of GDP in Turkey?
Keep it short and to the point. -1.54. In the year 2000, what is the difference between the % of GDP in Sub-Saharan Africa (all income levels) and % of GDP in Chile?
Provide a short and direct response. -6.45. In the year 2000, what is the difference between the % of GDP of Sub-Saharan Africa (all income levels) and % of GDP of Paraguay?
Your response must be concise. 0.52. In the year 2000, what is the difference between the % of GDP in Sub-Saharan Africa (all income levels) and % of GDP in Turkey?
Your response must be concise. -4.48. In the year 2000, what is the difference between the % of GDP in Chile and % of GDP in Paraguay?
Keep it short and to the point. 6.97. In the year 2000, what is the difference between the % of GDP of Chile and % of GDP of Turkey?
Provide a short and direct response. 1.97. In the year 2000, what is the difference between the % of GDP in Paraguay and % of GDP in Turkey?
Ensure brevity in your answer.  -4.99. In the year 2001, what is the difference between the % of GDP in Sub-Saharan Africa (all income levels) and % of GDP in Chile?
Keep it short and to the point. -5.43. In the year 2001, what is the difference between the % of GDP of Sub-Saharan Africa (all income levels) and % of GDP of Paraguay?
Make the answer very short. 0.75. In the year 2001, what is the difference between the % of GDP in Sub-Saharan Africa (all income levels) and % of GDP in Turkey?
Ensure brevity in your answer.  1.41. In the year 2001, what is the difference between the % of GDP of Chile and % of GDP of Paraguay?
Give a very brief answer. 6.18. In the year 2001, what is the difference between the % of GDP of Chile and % of GDP of Turkey?
Keep it short and to the point. 6.84. In the year 2001, what is the difference between the % of GDP in Paraguay and % of GDP in Turkey?
Offer a terse response. 0.66. In the year 2002, what is the difference between the % of GDP in Sub-Saharan Africa (all income levels) and % of GDP in Chile?
Give a very brief answer. -4.84. In the year 2002, what is the difference between the % of GDP in Sub-Saharan Africa (all income levels) and % of GDP in Paraguay?
Your answer should be very brief. 1.42. In the year 2002, what is the difference between the % of GDP of Sub-Saharan Africa (all income levels) and % of GDP of Turkey?
Your answer should be compact. -1.14. In the year 2002, what is the difference between the % of GDP of Chile and % of GDP of Paraguay?
Offer a very short reply. 6.26. In the year 2002, what is the difference between the % of GDP in Chile and % of GDP in Turkey?
Your answer should be very brief. 3.7. In the year 2002, what is the difference between the % of GDP of Paraguay and % of GDP of Turkey?
Provide a succinct answer. -2.56. What is the ratio of the % of GDP of Sub-Saharan Africa (all income levels) in 1996 to that in 1997?
Provide a succinct answer. 1.04. What is the ratio of the % of GDP of Paraguay in 1996 to that in 1997?
Make the answer very short. 0.97. What is the ratio of the % of GDP in Turkey in 1996 to that in 1997?
Provide a succinct answer. 0.98. What is the ratio of the % of GDP in Sub-Saharan Africa (all income levels) in 1996 to that in 1998?
Ensure brevity in your answer.  0.96. What is the ratio of the % of GDP of Chile in 1996 to that in 1998?
Ensure brevity in your answer.  1.02. What is the ratio of the % of GDP in Paraguay in 1996 to that in 1998?
Your answer should be compact. 1.15. What is the ratio of the % of GDP in Turkey in 1996 to that in 1998?
Make the answer very short. 1.11. What is the ratio of the % of GDP in Sub-Saharan Africa (all income levels) in 1996 to that in 1999?
Your response must be concise. 1.05. What is the ratio of the % of GDP of Chile in 1996 to that in 1999?
Ensure brevity in your answer.  1.31. What is the ratio of the % of GDP of Paraguay in 1996 to that in 1999?
Ensure brevity in your answer.  1.26. What is the ratio of the % of GDP in Turkey in 1996 to that in 1999?
Ensure brevity in your answer.  1.28. What is the ratio of the % of GDP in Sub-Saharan Africa (all income levels) in 1996 to that in 2000?
Offer a terse response. 1.09. What is the ratio of the % of GDP in Chile in 1996 to that in 2000?
Give a very brief answer. 1.2. What is the ratio of the % of GDP of Paraguay in 1996 to that in 2000?
Provide a succinct answer. 1.4. What is the ratio of the % of GDP in Turkey in 1996 to that in 2000?
Ensure brevity in your answer.  1.18. What is the ratio of the % of GDP of Sub-Saharan Africa (all income levels) in 1996 to that in 2001?
Provide a short and direct response. 1.07. What is the ratio of the % of GDP of Chile in 1996 to that in 2001?
Offer a terse response. 1.25. What is the ratio of the % of GDP of Paraguay in 1996 to that in 2001?
Offer a terse response. 1.41. What is the ratio of the % of GDP of Turkey in 1996 to that in 2001?
Make the answer very short. 1.63. What is the ratio of the % of GDP in Sub-Saharan Africa (all income levels) in 1996 to that in 2002?
Keep it short and to the point. 1.07. What is the ratio of the % of GDP in Chile in 1996 to that in 2002?
Make the answer very short. 1.28. What is the ratio of the % of GDP of Paraguay in 1996 to that in 2002?
Offer a terse response. 1.47. What is the ratio of the % of GDP in Turkey in 1996 to that in 2002?
Ensure brevity in your answer.  1.39. What is the ratio of the % of GDP in Sub-Saharan Africa (all income levels) in 1997 to that in 1998?
Your answer should be very brief. 0.92. What is the ratio of the % of GDP of Chile in 1997 to that in 1998?
Provide a short and direct response. 1.03. What is the ratio of the % of GDP in Paraguay in 1997 to that in 1998?
Your answer should be very brief. 1.19. What is the ratio of the % of GDP in Turkey in 1997 to that in 1998?
Provide a short and direct response. 1.14. What is the ratio of the % of GDP of Sub-Saharan Africa (all income levels) in 1997 to that in 1999?
Give a very brief answer. 1.01. What is the ratio of the % of GDP of Chile in 1997 to that in 1999?
Your response must be concise. 1.33. What is the ratio of the % of GDP in Paraguay in 1997 to that in 1999?
Ensure brevity in your answer.  1.3. What is the ratio of the % of GDP in Turkey in 1997 to that in 1999?
Provide a succinct answer. 1.31. What is the ratio of the % of GDP of Sub-Saharan Africa (all income levels) in 1997 to that in 2000?
Your answer should be very brief. 1.04. What is the ratio of the % of GDP in Chile in 1997 to that in 2000?
Make the answer very short. 1.22. What is the ratio of the % of GDP in Paraguay in 1997 to that in 2000?
Offer a terse response. 1.45. What is the ratio of the % of GDP in Turkey in 1997 to that in 2000?
Your answer should be compact. 1.21. What is the ratio of the % of GDP in Sub-Saharan Africa (all income levels) in 1997 to that in 2001?
Offer a terse response. 1.03. What is the ratio of the % of GDP in Chile in 1997 to that in 2001?
Keep it short and to the point. 1.26. What is the ratio of the % of GDP of Paraguay in 1997 to that in 2001?
Your answer should be very brief. 1.46. What is the ratio of the % of GDP of Turkey in 1997 to that in 2001?
Give a very brief answer. 1.66. What is the ratio of the % of GDP in Sub-Saharan Africa (all income levels) in 1997 to that in 2002?
Give a very brief answer. 1.03. What is the ratio of the % of GDP of Chile in 1997 to that in 2002?
Your response must be concise. 1.3. What is the ratio of the % of GDP of Paraguay in 1997 to that in 2002?
Give a very brief answer. 1.52. What is the ratio of the % of GDP of Turkey in 1997 to that in 2002?
Your answer should be compact. 1.43. What is the ratio of the % of GDP in Sub-Saharan Africa (all income levels) in 1998 to that in 1999?
Give a very brief answer. 1.09. What is the ratio of the % of GDP of Chile in 1998 to that in 1999?
Your answer should be compact. 1.29. What is the ratio of the % of GDP of Paraguay in 1998 to that in 1999?
Keep it short and to the point. 1.1. What is the ratio of the % of GDP in Turkey in 1998 to that in 1999?
Keep it short and to the point. 1.16. What is the ratio of the % of GDP of Sub-Saharan Africa (all income levels) in 1998 to that in 2000?
Make the answer very short. 1.13. What is the ratio of the % of GDP in Chile in 1998 to that in 2000?
Provide a succinct answer. 1.18. What is the ratio of the % of GDP of Paraguay in 1998 to that in 2000?
Give a very brief answer. 1.23. What is the ratio of the % of GDP of Turkey in 1998 to that in 2000?
Your response must be concise. 1.06. What is the ratio of the % of GDP in Sub-Saharan Africa (all income levels) in 1998 to that in 2001?
Your response must be concise. 1.12. What is the ratio of the % of GDP in Chile in 1998 to that in 2001?
Provide a short and direct response. 1.23. What is the ratio of the % of GDP in Paraguay in 1998 to that in 2001?
Provide a succinct answer. 1.23. What is the ratio of the % of GDP in Turkey in 1998 to that in 2001?
Ensure brevity in your answer.  1.47. What is the ratio of the % of GDP in Sub-Saharan Africa (all income levels) in 1998 to that in 2002?
Provide a short and direct response. 1.12. What is the ratio of the % of GDP of Chile in 1998 to that in 2002?
Make the answer very short. 1.26. What is the ratio of the % of GDP of Paraguay in 1998 to that in 2002?
Keep it short and to the point. 1.28. What is the ratio of the % of GDP of Turkey in 1998 to that in 2002?
Provide a short and direct response. 1.26. What is the ratio of the % of GDP in Sub-Saharan Africa (all income levels) in 1999 to that in 2000?
Your answer should be compact. 1.03. What is the ratio of the % of GDP in Chile in 1999 to that in 2000?
Offer a very short reply. 0.92. What is the ratio of the % of GDP in Paraguay in 1999 to that in 2000?
Offer a terse response. 1.12. What is the ratio of the % of GDP of Turkey in 1999 to that in 2000?
Keep it short and to the point. 0.92. What is the ratio of the % of GDP in Chile in 1999 to that in 2001?
Your response must be concise. 0.95. What is the ratio of the % of GDP in Paraguay in 1999 to that in 2001?
Provide a short and direct response. 1.12. What is the ratio of the % of GDP of Turkey in 1999 to that in 2001?
Keep it short and to the point. 1.27. What is the ratio of the % of GDP in Sub-Saharan Africa (all income levels) in 1999 to that in 2002?
Your answer should be very brief. 1.02. What is the ratio of the % of GDP of Chile in 1999 to that in 2002?
Keep it short and to the point. 0.98. What is the ratio of the % of GDP in Paraguay in 1999 to that in 2002?
Offer a very short reply. 1.17. What is the ratio of the % of GDP in Turkey in 1999 to that in 2002?
Keep it short and to the point. 1.09. What is the ratio of the % of GDP of Sub-Saharan Africa (all income levels) in 2000 to that in 2001?
Your response must be concise. 0.99. What is the ratio of the % of GDP of Chile in 2000 to that in 2001?
Offer a very short reply. 1.04. What is the ratio of the % of GDP of Paraguay in 2000 to that in 2001?
Your answer should be very brief. 1. What is the ratio of the % of GDP of Turkey in 2000 to that in 2001?
Make the answer very short. 1.38. What is the ratio of the % of GDP in Sub-Saharan Africa (all income levels) in 2000 to that in 2002?
Your answer should be very brief. 0.99. What is the ratio of the % of GDP of Chile in 2000 to that in 2002?
Ensure brevity in your answer.  1.07. What is the ratio of the % of GDP of Paraguay in 2000 to that in 2002?
Your answer should be very brief. 1.05. What is the ratio of the % of GDP of Turkey in 2000 to that in 2002?
Provide a short and direct response. 1.18. What is the ratio of the % of GDP of Sub-Saharan Africa (all income levels) in 2001 to that in 2002?
Keep it short and to the point. 1. What is the ratio of the % of GDP of Chile in 2001 to that in 2002?
Ensure brevity in your answer.  1.03. What is the ratio of the % of GDP in Paraguay in 2001 to that in 2002?
Your answer should be very brief. 1.05. What is the ratio of the % of GDP in Turkey in 2001 to that in 2002?
Make the answer very short. 0.86. What is the difference between the highest and the second highest % of GDP in Sub-Saharan Africa (all income levels)?
Provide a short and direct response. 0.74. What is the difference between the highest and the second highest % of GDP of Chile?
Your answer should be compact. 0.34. What is the difference between the highest and the second highest % of GDP in Paraguay?
Give a very brief answer. 0.79. What is the difference between the highest and the second highest % of GDP in Turkey?
Provide a succinct answer. 0.56. What is the difference between the highest and the lowest % of GDP in Sub-Saharan Africa (all income levels)?
Your answer should be compact. 2.13. What is the difference between the highest and the lowest % of GDP in Chile?
Give a very brief answer. 6.82. What is the difference between the highest and the lowest % of GDP in Paraguay?
Your answer should be very brief. 7.86. What is the difference between the highest and the lowest % of GDP of Turkey?
Your response must be concise. 10.03. 